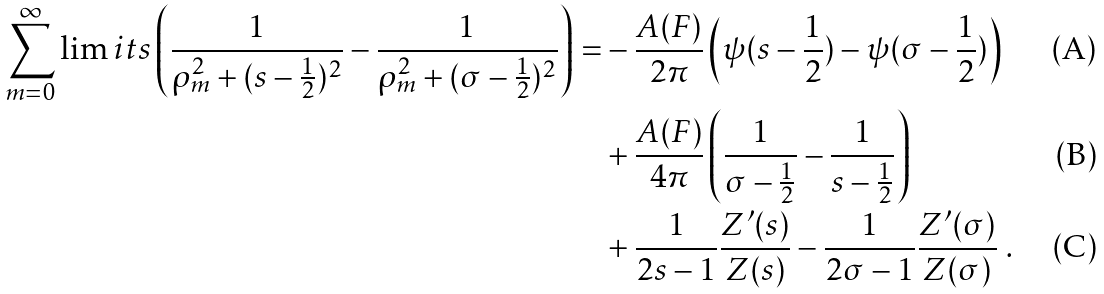<formula> <loc_0><loc_0><loc_500><loc_500>\sum _ { m = 0 } ^ { \infty } \lim i t s \left ( \frac { 1 } { \rho _ { m } ^ { 2 } + ( s - \frac { 1 } { 2 } ) ^ { 2 } } - \frac { 1 } { \rho _ { m } ^ { 2 } + ( \sigma - \frac { 1 } { 2 } ) ^ { 2 } } \right ) = & - \frac { A ( F ) } { 2 \pi } \left ( \psi ( s - \frac { 1 } { 2 } ) - \psi ( \sigma - \frac { 1 } { 2 } ) \right ) \\ & + \frac { A ( F ) } { 4 \pi } \left ( \frac { 1 } { \sigma - \frac { 1 } { 2 } } - \frac { 1 } { s - \frac { 1 } { 2 } } \right ) \\ & + \frac { 1 } { 2 s - 1 } \frac { Z ^ { \prime } ( s ) } { Z ( s ) } - \frac { 1 } { 2 \sigma - 1 } \frac { Z ^ { \prime } ( \sigma ) } { Z ( \sigma ) } \ .</formula> 